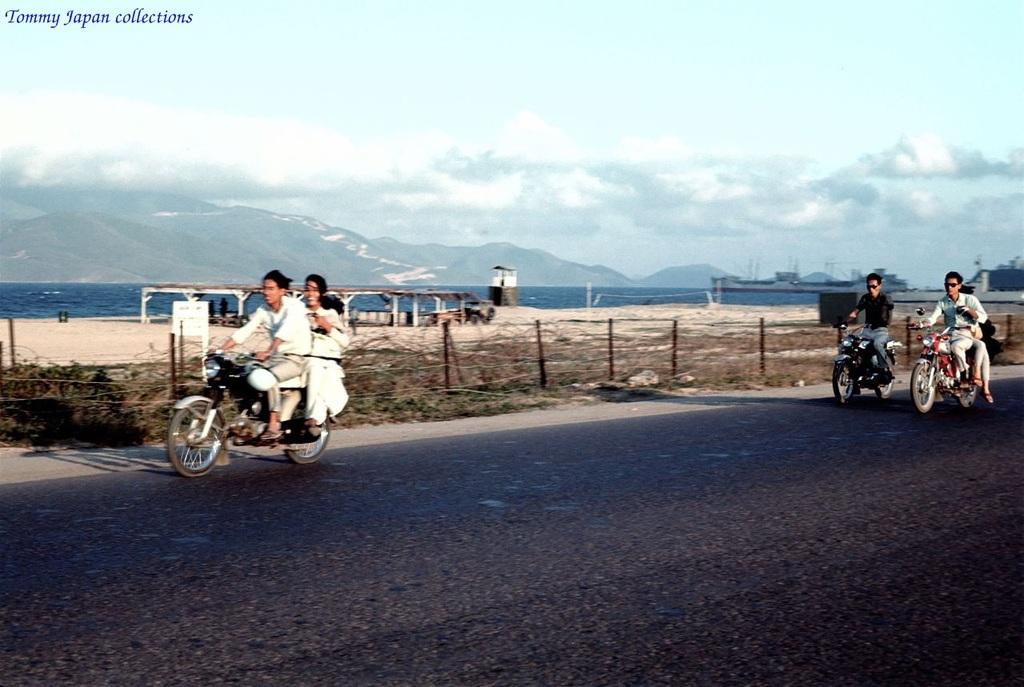Describe this image in one or two sentences. As we can see in the image there is a sky, hills, water, road and on road there are few motorcycles and few people sitting on motorcycles. 